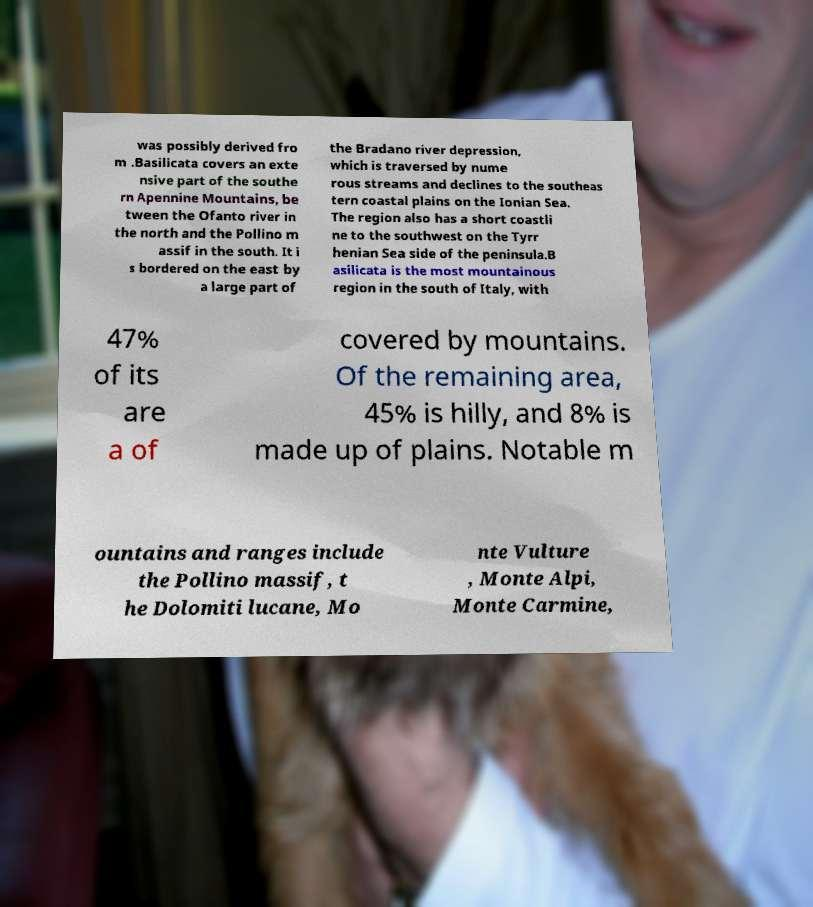For documentation purposes, I need the text within this image transcribed. Could you provide that? was possibly derived fro m .Basilicata covers an exte nsive part of the southe rn Apennine Mountains, be tween the Ofanto river in the north and the Pollino m assif in the south. It i s bordered on the east by a large part of the Bradano river depression, which is traversed by nume rous streams and declines to the southeas tern coastal plains on the Ionian Sea. The region also has a short coastli ne to the southwest on the Tyrr henian Sea side of the peninsula.B asilicata is the most mountainous region in the south of Italy, with 47% of its are a of covered by mountains. Of the remaining area, 45% is hilly, and 8% is made up of plains. Notable m ountains and ranges include the Pollino massif, t he Dolomiti lucane, Mo nte Vulture , Monte Alpi, Monte Carmine, 